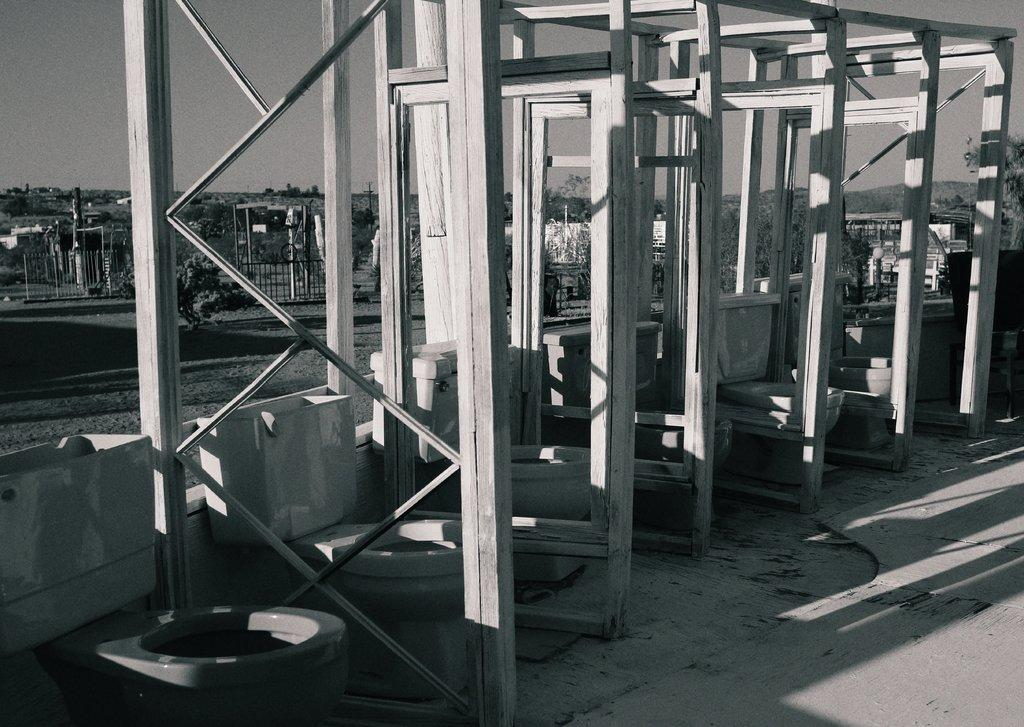What is the color scheme of the image? The image is black and white. What objects can be seen in the image? There are rods, commodes, and flush tanks in the image. What can be seen in the background of the image? In the background, there are plants, fences, metal objects, trees, and the sky. Can you see a cat walking down the street in the image? There is no cat or street present in the image. What type of bird can be seen perched on the wren in the image? There is no bird or wren present in the image. 